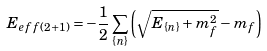<formula> <loc_0><loc_0><loc_500><loc_500>E _ { e f f ( 2 + 1 ) } = - \frac { 1 } { 2 } \sum _ { \{ n \} } \left ( \sqrt { E _ { \{ n \} } + m ^ { 2 } _ { f } } - m _ { f } \right )</formula> 